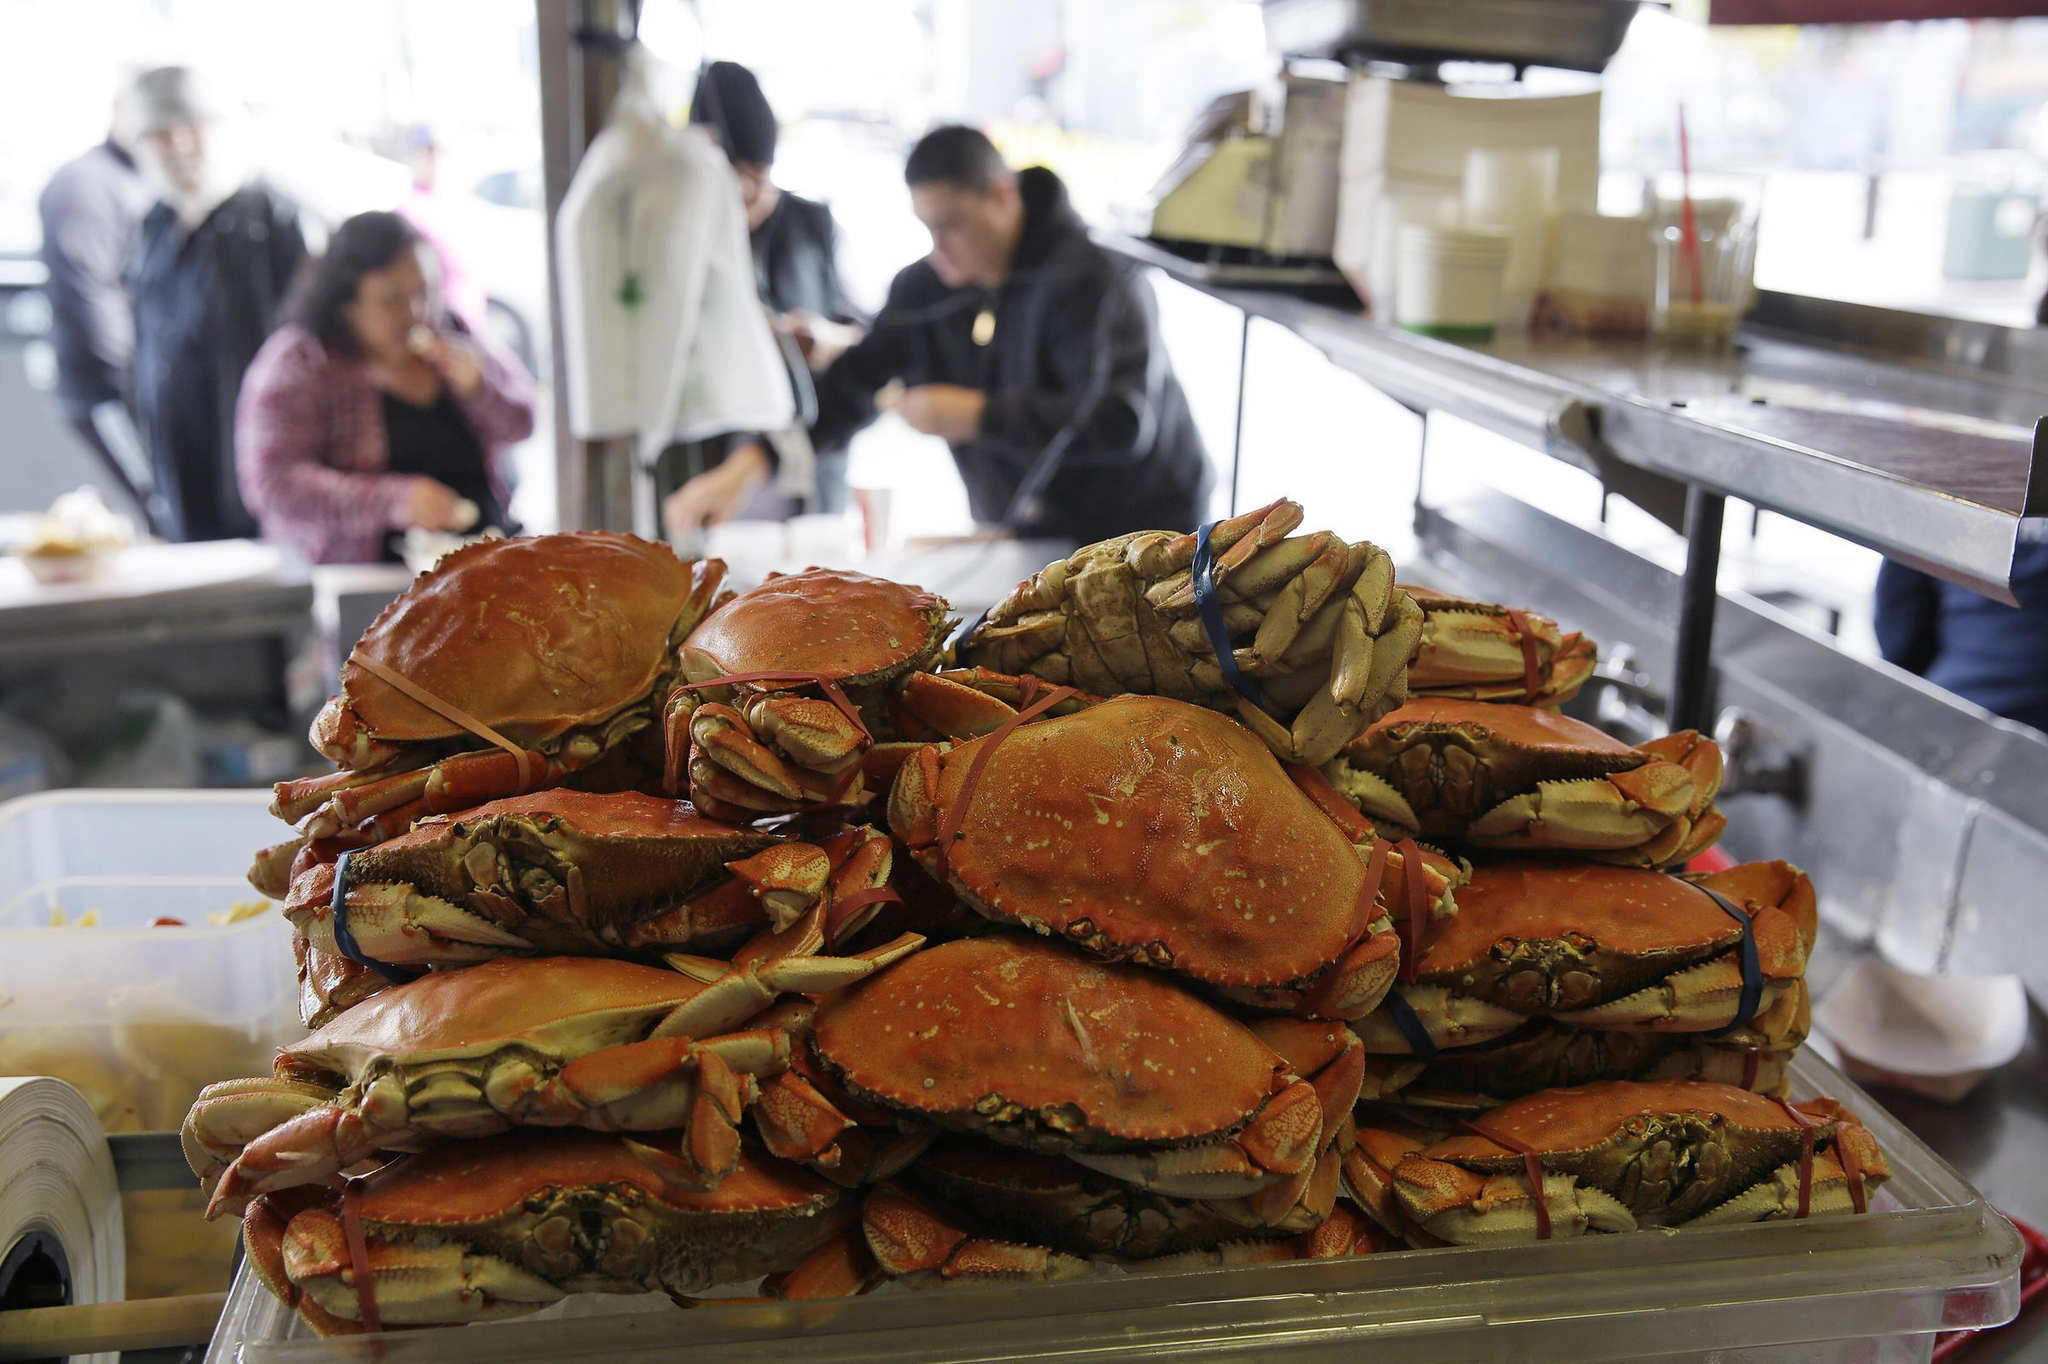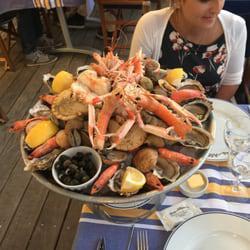The first image is the image on the left, the second image is the image on the right. Assess this claim about the two images: "A single person who is a woman is sitting behind a platter of seafood in one of the images.". Correct or not? Answer yes or no. Yes. 